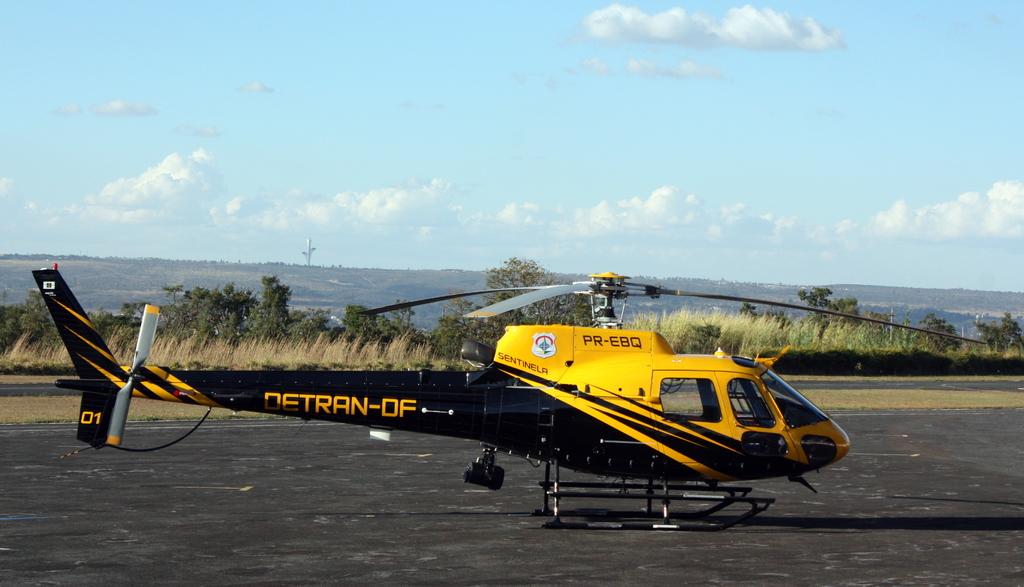What number is shown on the tail of the helicopter?
Keep it short and to the point. 01. 